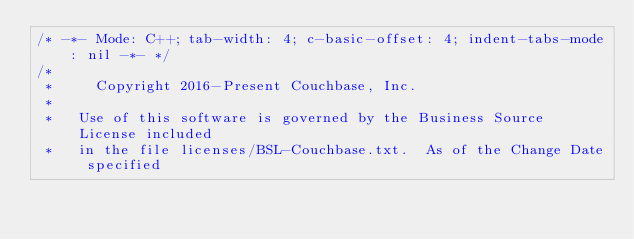Convert code to text. <code><loc_0><loc_0><loc_500><loc_500><_C++_>/* -*- Mode: C++; tab-width: 4; c-basic-offset: 4; indent-tabs-mode: nil -*- */
/*
 *     Copyright 2016-Present Couchbase, Inc.
 *
 *   Use of this software is governed by the Business Source License included
 *   in the file licenses/BSL-Couchbase.txt.  As of the Change Date specified</code> 